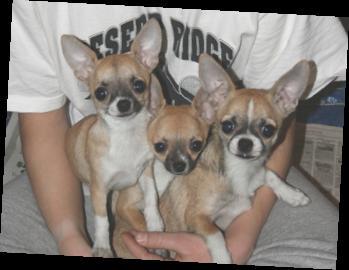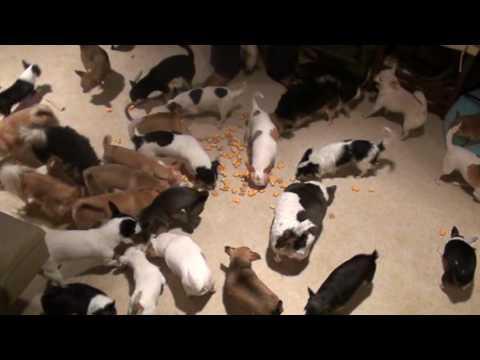The first image is the image on the left, the second image is the image on the right. For the images shown, is this caption "There is exactly one real dog in the image on the left." true? Answer yes or no. No. 